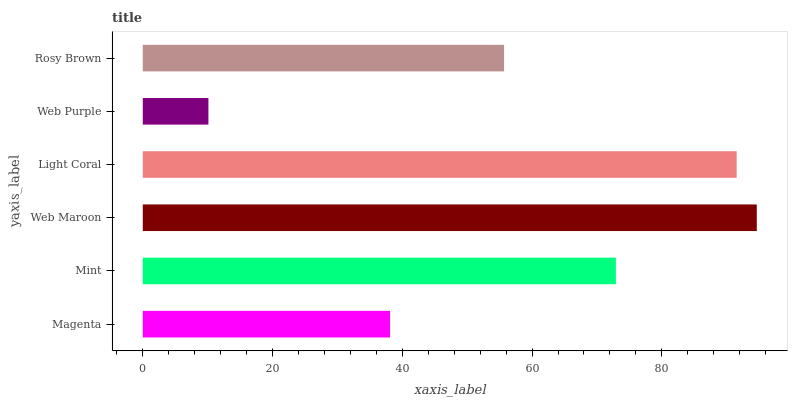Is Web Purple the minimum?
Answer yes or no. Yes. Is Web Maroon the maximum?
Answer yes or no. Yes. Is Mint the minimum?
Answer yes or no. No. Is Mint the maximum?
Answer yes or no. No. Is Mint greater than Magenta?
Answer yes or no. Yes. Is Magenta less than Mint?
Answer yes or no. Yes. Is Magenta greater than Mint?
Answer yes or no. No. Is Mint less than Magenta?
Answer yes or no. No. Is Mint the high median?
Answer yes or no. Yes. Is Rosy Brown the low median?
Answer yes or no. Yes. Is Rosy Brown the high median?
Answer yes or no. No. Is Magenta the low median?
Answer yes or no. No. 